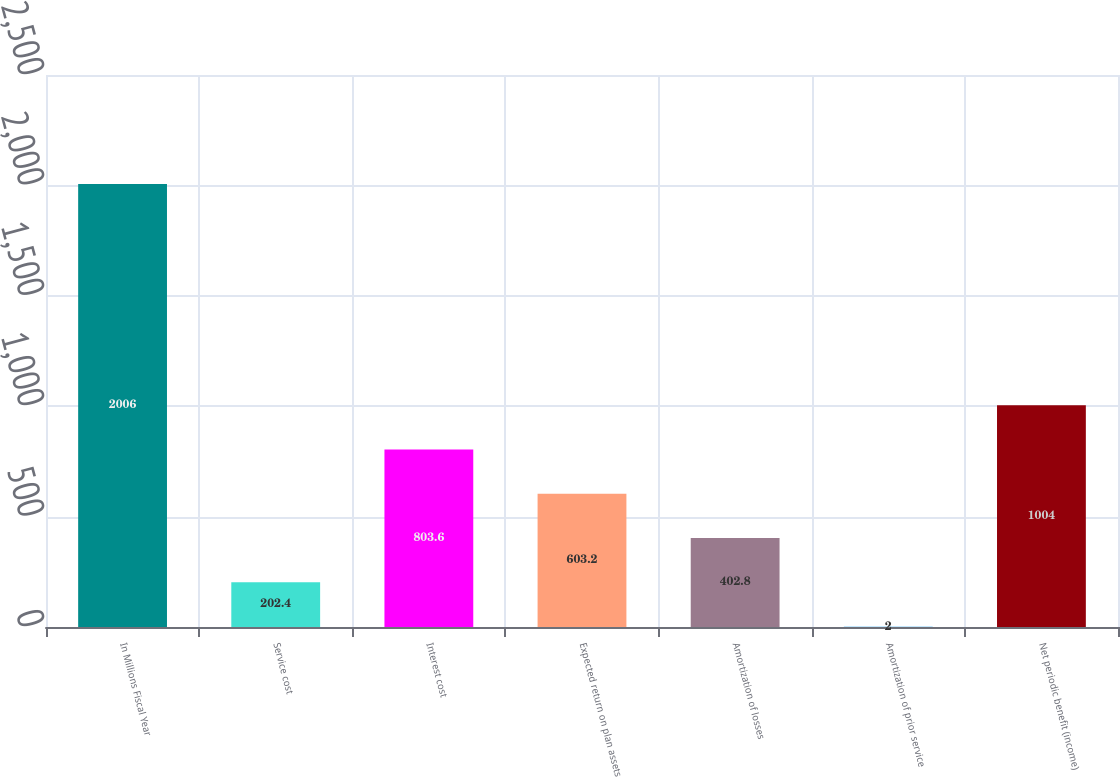Convert chart to OTSL. <chart><loc_0><loc_0><loc_500><loc_500><bar_chart><fcel>In Millions Fiscal Year<fcel>Service cost<fcel>Interest cost<fcel>Expected return on plan assets<fcel>Amortization of losses<fcel>Amortization of prior service<fcel>Net periodic benefit (income)<nl><fcel>2006<fcel>202.4<fcel>803.6<fcel>603.2<fcel>402.8<fcel>2<fcel>1004<nl></chart> 